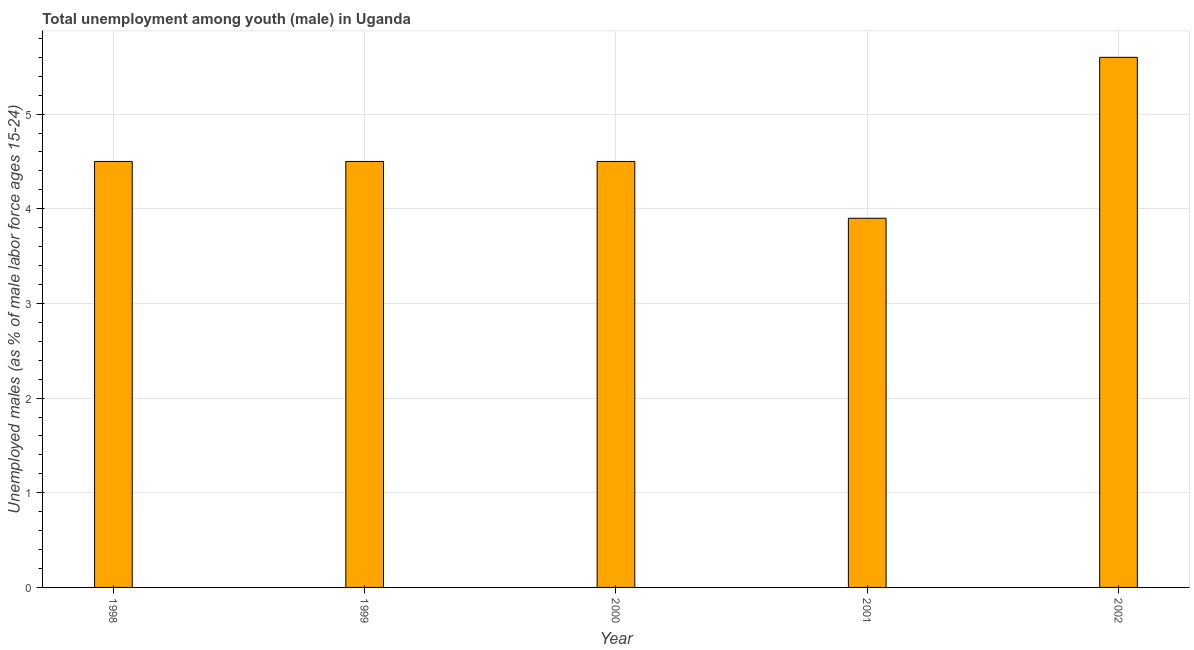What is the title of the graph?
Offer a terse response. Total unemployment among youth (male) in Uganda. What is the label or title of the X-axis?
Your answer should be compact. Year. What is the label or title of the Y-axis?
Your answer should be very brief. Unemployed males (as % of male labor force ages 15-24). Across all years, what is the maximum unemployed male youth population?
Give a very brief answer. 5.6. Across all years, what is the minimum unemployed male youth population?
Provide a short and direct response. 3.9. In which year was the unemployed male youth population maximum?
Provide a short and direct response. 2002. In which year was the unemployed male youth population minimum?
Your answer should be compact. 2001. What is the sum of the unemployed male youth population?
Your answer should be compact. 23. What is the difference between the unemployed male youth population in 1998 and 1999?
Your response must be concise. 0. What is the average unemployed male youth population per year?
Make the answer very short. 4.6. What is the median unemployed male youth population?
Your answer should be compact. 4.5. In how many years, is the unemployed male youth population greater than 5.4 %?
Your response must be concise. 1. What is the ratio of the unemployed male youth population in 1998 to that in 2002?
Offer a terse response. 0.8. In how many years, is the unemployed male youth population greater than the average unemployed male youth population taken over all years?
Keep it short and to the point. 1. How many bars are there?
Your response must be concise. 5. How many years are there in the graph?
Offer a terse response. 5. Are the values on the major ticks of Y-axis written in scientific E-notation?
Ensure brevity in your answer.  No. What is the Unemployed males (as % of male labor force ages 15-24) in 1998?
Your answer should be compact. 4.5. What is the Unemployed males (as % of male labor force ages 15-24) of 1999?
Give a very brief answer. 4.5. What is the Unemployed males (as % of male labor force ages 15-24) of 2001?
Make the answer very short. 3.9. What is the Unemployed males (as % of male labor force ages 15-24) of 2002?
Give a very brief answer. 5.6. What is the difference between the Unemployed males (as % of male labor force ages 15-24) in 1998 and 1999?
Provide a short and direct response. 0. What is the difference between the Unemployed males (as % of male labor force ages 15-24) in 1998 and 2002?
Provide a succinct answer. -1.1. What is the difference between the Unemployed males (as % of male labor force ages 15-24) in 1999 and 2000?
Your response must be concise. 0. What is the difference between the Unemployed males (as % of male labor force ages 15-24) in 1999 and 2002?
Give a very brief answer. -1.1. What is the difference between the Unemployed males (as % of male labor force ages 15-24) in 2000 and 2002?
Your answer should be very brief. -1.1. What is the difference between the Unemployed males (as % of male labor force ages 15-24) in 2001 and 2002?
Keep it short and to the point. -1.7. What is the ratio of the Unemployed males (as % of male labor force ages 15-24) in 1998 to that in 1999?
Your answer should be very brief. 1. What is the ratio of the Unemployed males (as % of male labor force ages 15-24) in 1998 to that in 2001?
Give a very brief answer. 1.15. What is the ratio of the Unemployed males (as % of male labor force ages 15-24) in 1998 to that in 2002?
Give a very brief answer. 0.8. What is the ratio of the Unemployed males (as % of male labor force ages 15-24) in 1999 to that in 2000?
Your answer should be very brief. 1. What is the ratio of the Unemployed males (as % of male labor force ages 15-24) in 1999 to that in 2001?
Your answer should be compact. 1.15. What is the ratio of the Unemployed males (as % of male labor force ages 15-24) in 1999 to that in 2002?
Offer a very short reply. 0.8. What is the ratio of the Unemployed males (as % of male labor force ages 15-24) in 2000 to that in 2001?
Provide a short and direct response. 1.15. What is the ratio of the Unemployed males (as % of male labor force ages 15-24) in 2000 to that in 2002?
Keep it short and to the point. 0.8. What is the ratio of the Unemployed males (as % of male labor force ages 15-24) in 2001 to that in 2002?
Provide a succinct answer. 0.7. 